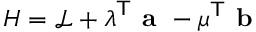Convert formula to latex. <formula><loc_0><loc_0><loc_500><loc_500>H = { \mathcal { L } } + { \lambda } ^ { T } { a } - { \mu } ^ { T } { b }</formula> 